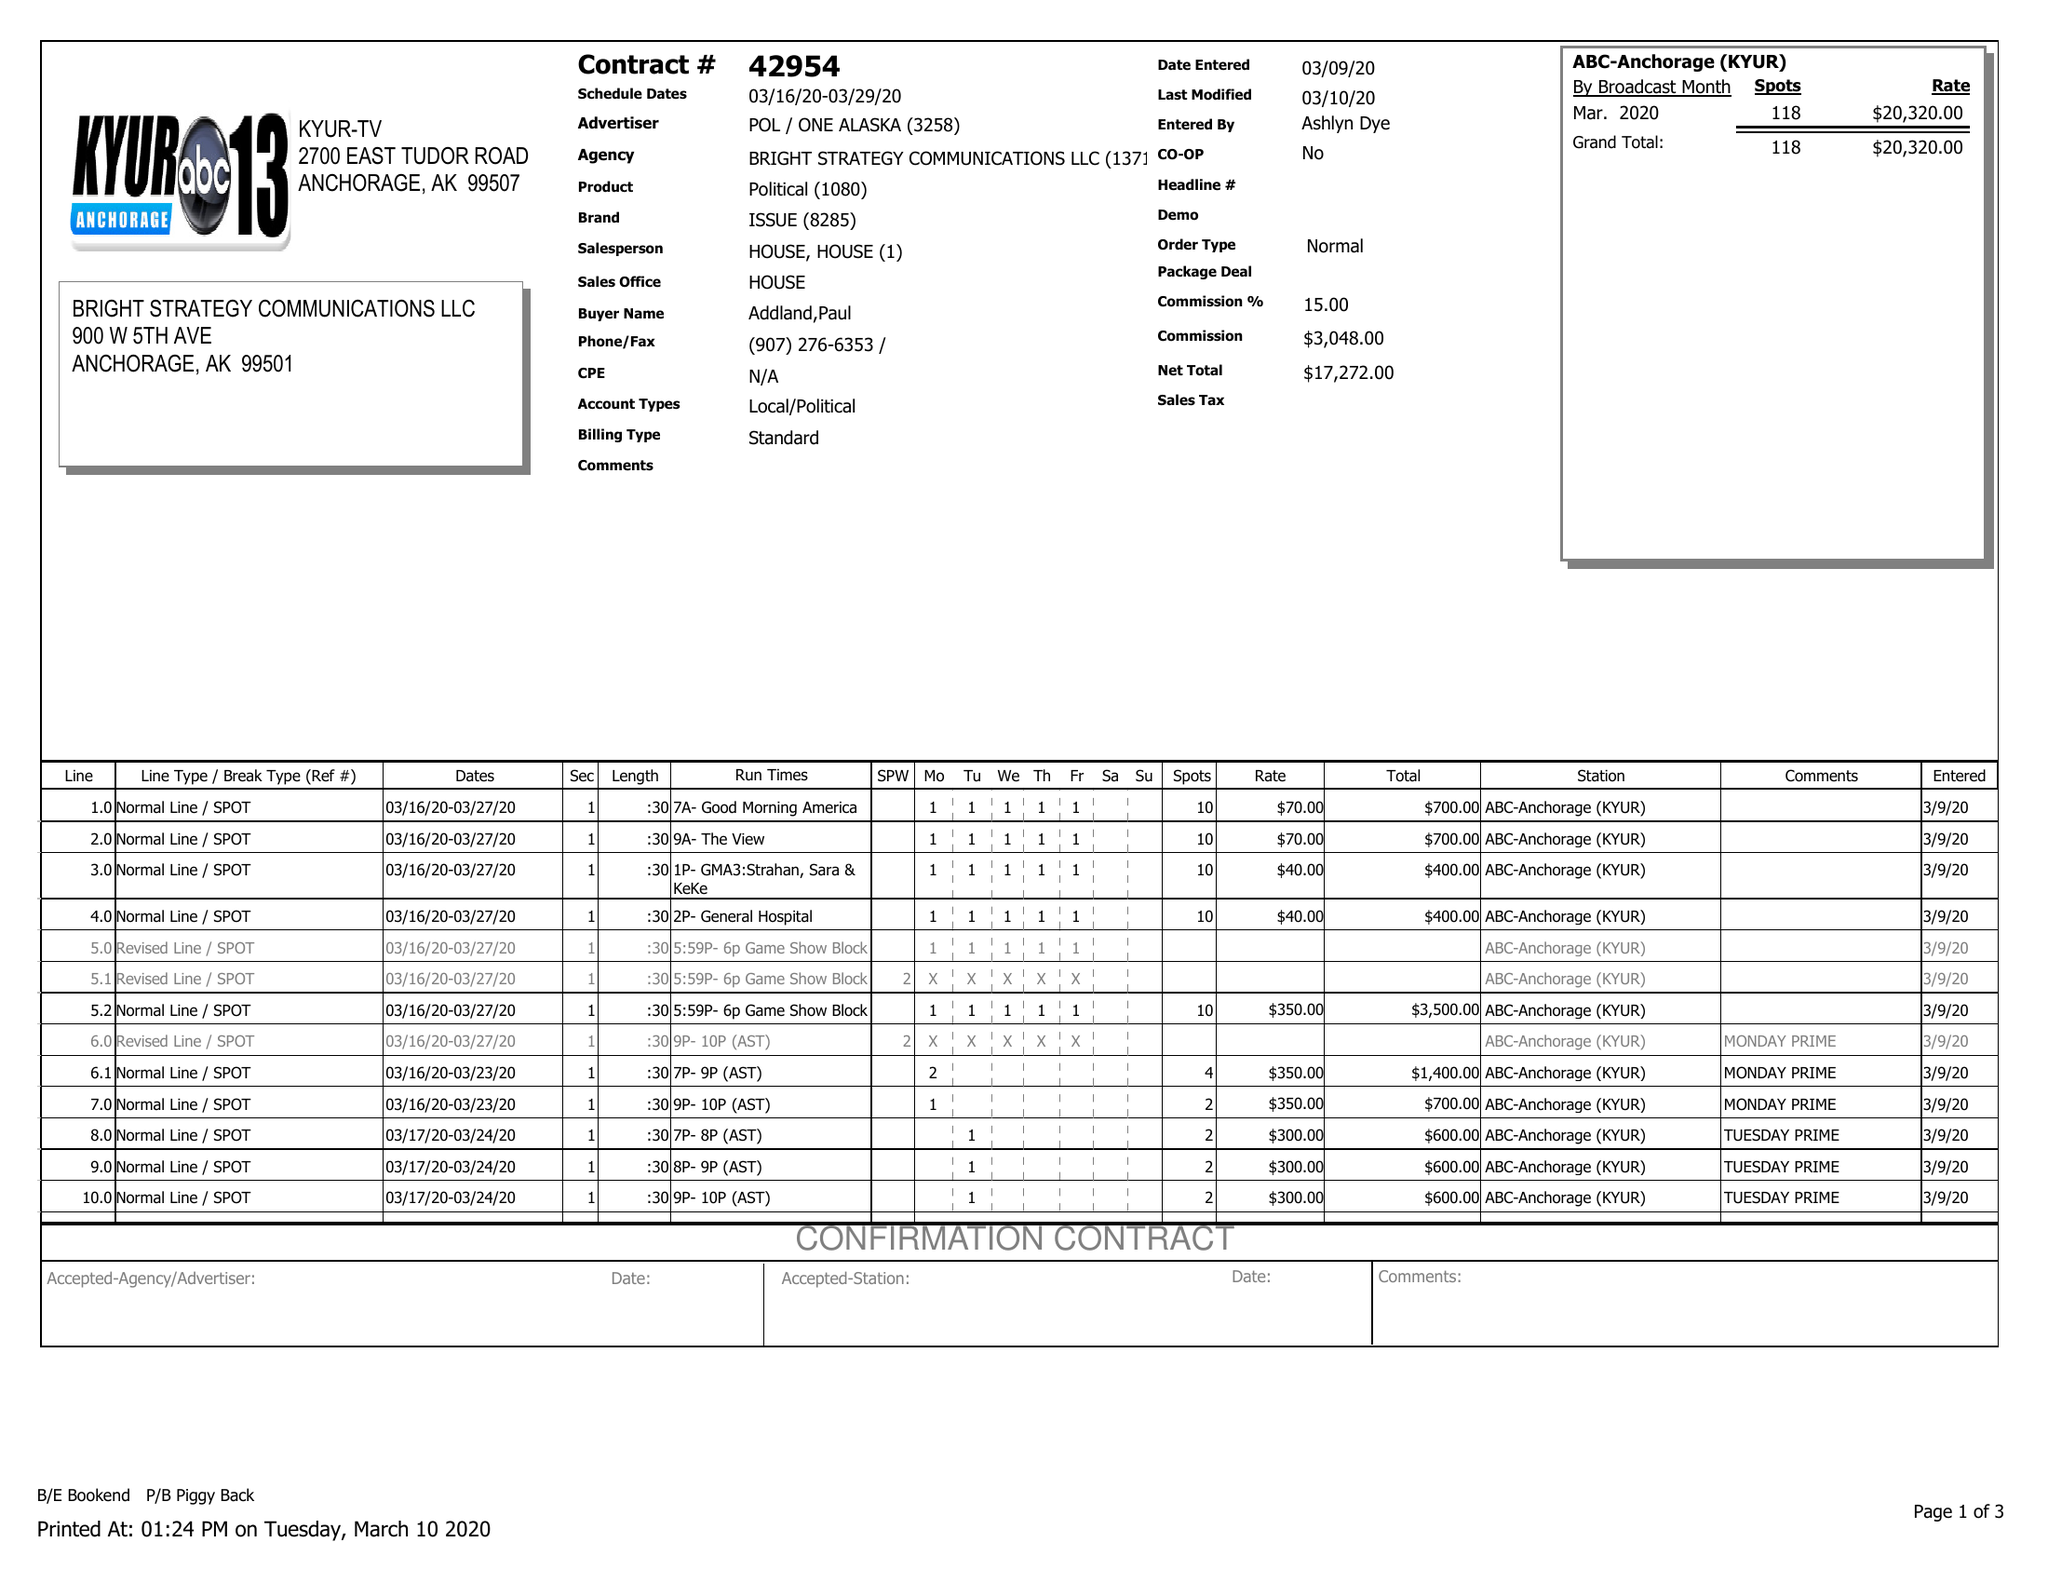What is the value for the gross_amount?
Answer the question using a single word or phrase. 20320.00 